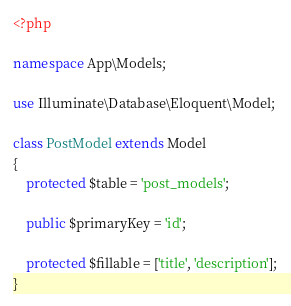<code> <loc_0><loc_0><loc_500><loc_500><_PHP_><?php

namespace App\Models;

use Illuminate\Database\Eloquent\Model;

class PostModel extends Model
{
    protected $table = 'post_models';

    public $primaryKey = 'id';

    protected $fillable = ['title', 'description'];
}
</code> 